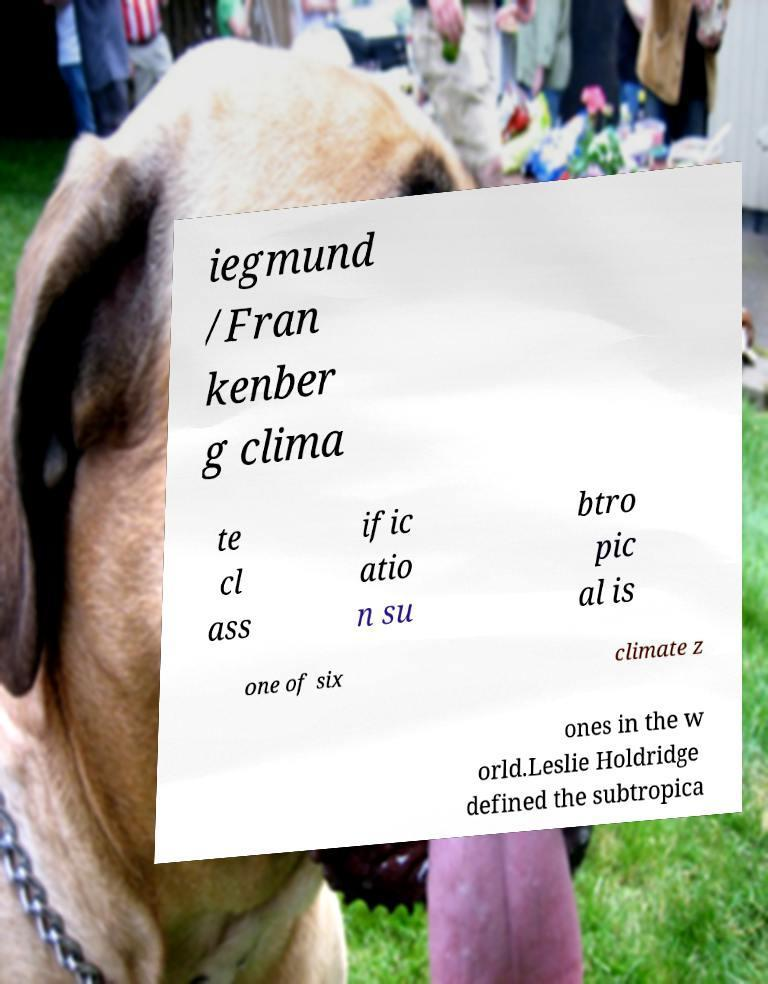For documentation purposes, I need the text within this image transcribed. Could you provide that? iegmund /Fran kenber g clima te cl ass ific atio n su btro pic al is one of six climate z ones in the w orld.Leslie Holdridge defined the subtropica 